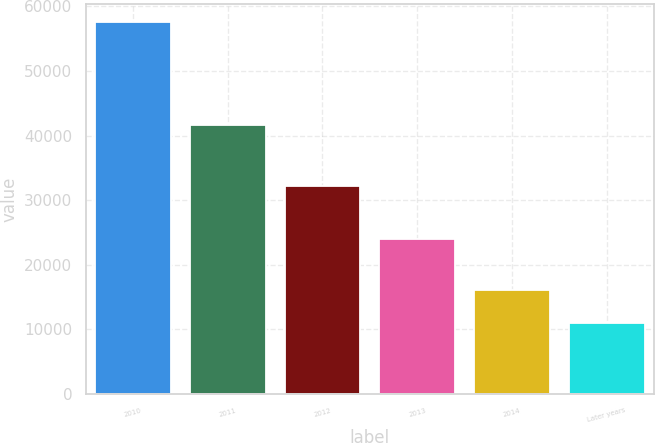Convert chart. <chart><loc_0><loc_0><loc_500><loc_500><bar_chart><fcel>2010<fcel>2011<fcel>2012<fcel>2013<fcel>2014<fcel>Later years<nl><fcel>57569<fcel>41605<fcel>32134<fcel>24072<fcel>16109<fcel>10929<nl></chart> 